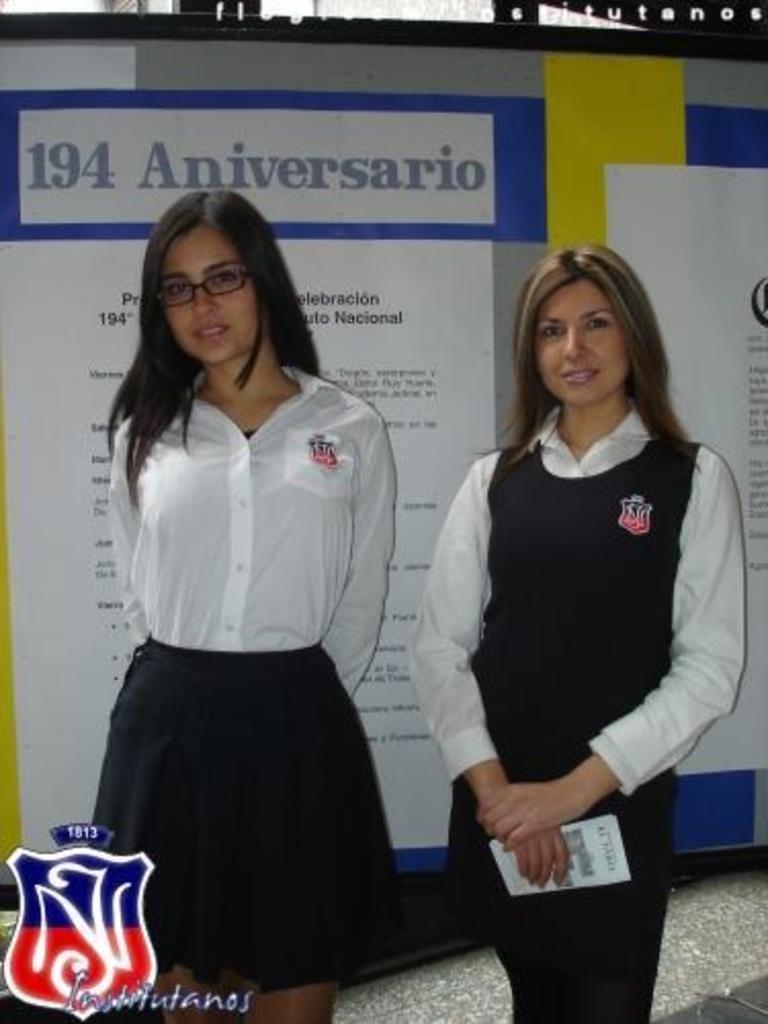How would you summarize this image in a sentence or two? In this picture there are two people standing. At the back there are boards, there is text on the boards. At the top there is text. At the bottom there is a floor. At the bottom left there is text and there might be a logo. 